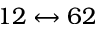Convert formula to latex. <formula><loc_0><loc_0><loc_500><loc_500>1 2 \leftrightarrow 6 2</formula> 